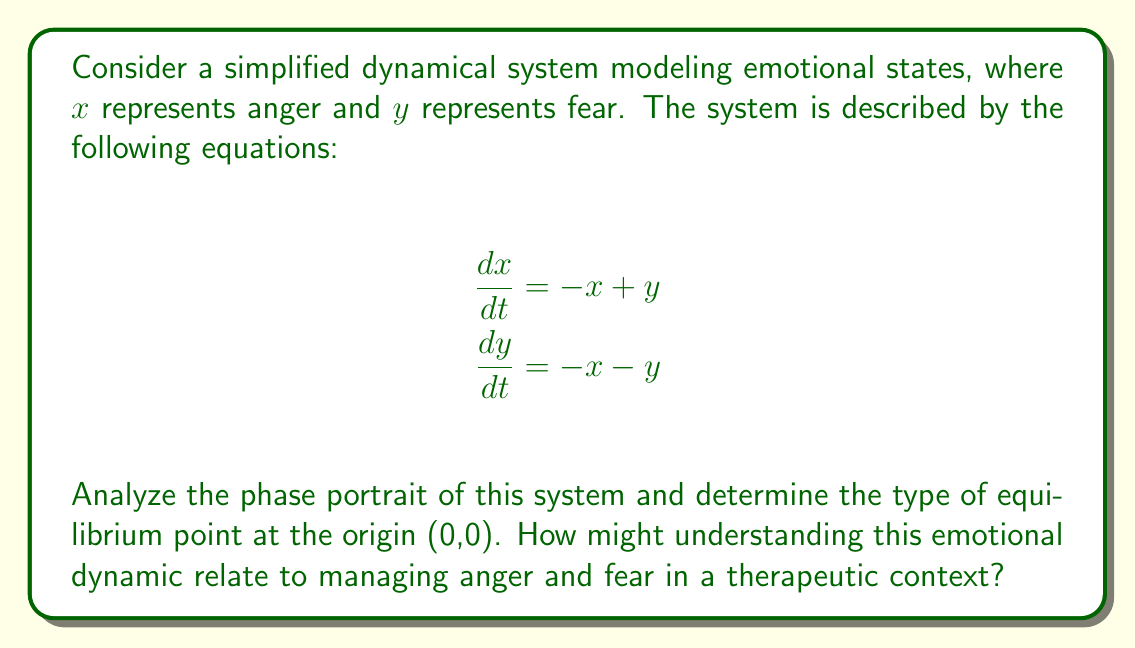Could you help me with this problem? To analyze the phase portrait and determine the type of equilibrium point, we'll follow these steps:

1. Find the equilibrium point(s):
   Set $\frac{dx}{dt} = 0$ and $\frac{dy}{dt} = 0$:
   $-x + y = 0$ and $-x - y = 0$
   Solving these equations simultaneously gives us $(x,y) = (0,0)$, confirming the origin as the only equilibrium point.

2. Linearize the system around the equilibrium point:
   The Jacobian matrix at (0,0) is:
   $$J = \begin{bmatrix} 
   -1 & 1 \\
   -1 & -1
   \end{bmatrix}$$

3. Find the eigenvalues of the Jacobian:
   Characteristic equation: $det(J - \lambda I) = 0$
   $$(1+\lambda)(1+\lambda) + 1 = 0$$
   $$\lambda^2 + 2\lambda + 2 = 0$$
   Solving this quadratic equation:
   $$\lambda = -1 \pm i$$

4. Determine the type of equilibrium:
   The eigenvalues are complex conjugates with negative real parts, indicating a stable focus (spiral sink).

5. Interpret the phase portrait:
   Trajectories spiral inward towards the origin, representing a gradual decrease in both anger and fear over time.

In a therapeutic context, this model suggests that anger and fear are interconnected emotions that tend to diminish together over time when left unperturbed. Understanding this dynamic could help in developing strategies to manage these emotions, recognizing that addressing one emotion (e.g., anger) may also impact the other (fear). The spiral nature implies that the process of emotional regulation may involve oscillations between these states before reaching a calm equilibrium.
Answer: Stable focus (spiral sink) 